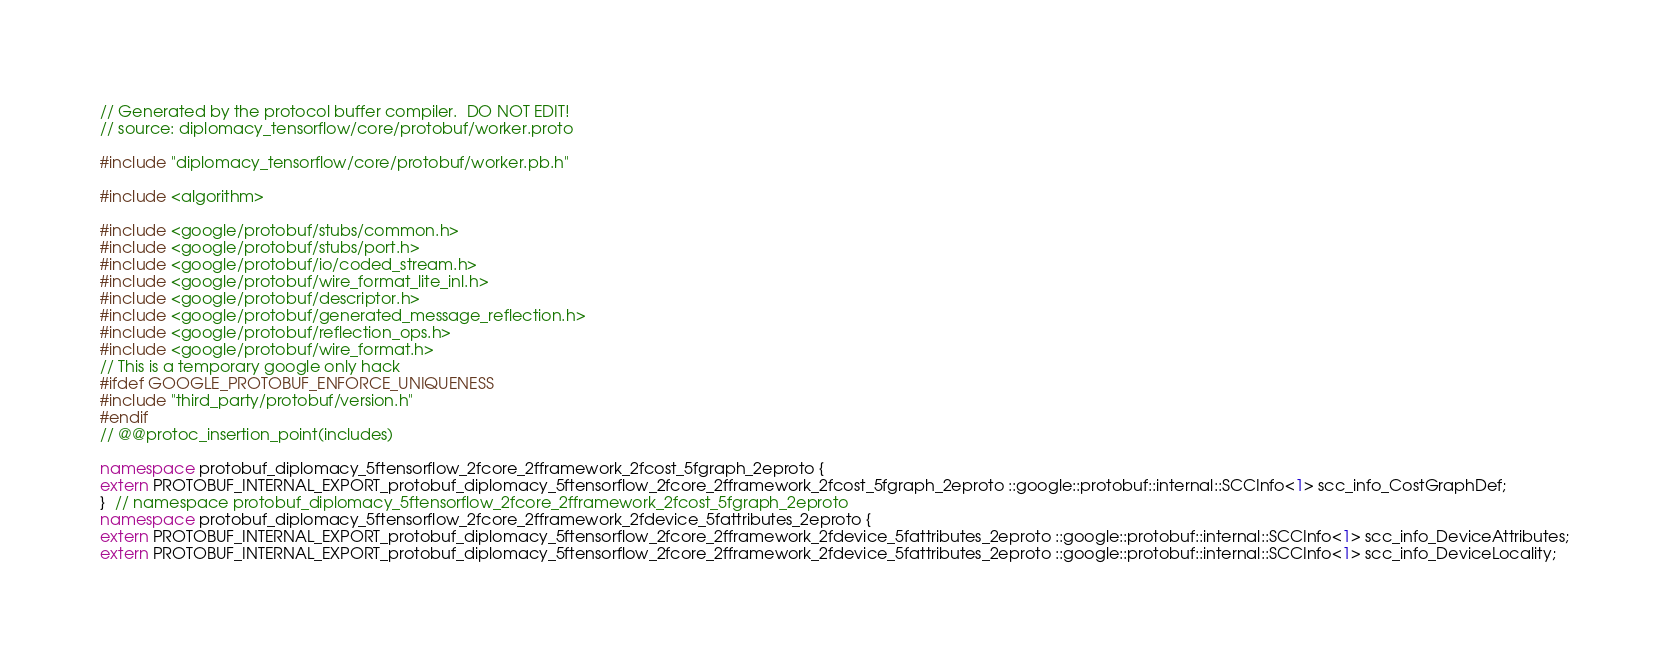Convert code to text. <code><loc_0><loc_0><loc_500><loc_500><_C++_>// Generated by the protocol buffer compiler.  DO NOT EDIT!
// source: diplomacy_tensorflow/core/protobuf/worker.proto

#include "diplomacy_tensorflow/core/protobuf/worker.pb.h"

#include <algorithm>

#include <google/protobuf/stubs/common.h>
#include <google/protobuf/stubs/port.h>
#include <google/protobuf/io/coded_stream.h>
#include <google/protobuf/wire_format_lite_inl.h>
#include <google/protobuf/descriptor.h>
#include <google/protobuf/generated_message_reflection.h>
#include <google/protobuf/reflection_ops.h>
#include <google/protobuf/wire_format.h>
// This is a temporary google only hack
#ifdef GOOGLE_PROTOBUF_ENFORCE_UNIQUENESS
#include "third_party/protobuf/version.h"
#endif
// @@protoc_insertion_point(includes)

namespace protobuf_diplomacy_5ftensorflow_2fcore_2fframework_2fcost_5fgraph_2eproto {
extern PROTOBUF_INTERNAL_EXPORT_protobuf_diplomacy_5ftensorflow_2fcore_2fframework_2fcost_5fgraph_2eproto ::google::protobuf::internal::SCCInfo<1> scc_info_CostGraphDef;
}  // namespace protobuf_diplomacy_5ftensorflow_2fcore_2fframework_2fcost_5fgraph_2eproto
namespace protobuf_diplomacy_5ftensorflow_2fcore_2fframework_2fdevice_5fattributes_2eproto {
extern PROTOBUF_INTERNAL_EXPORT_protobuf_diplomacy_5ftensorflow_2fcore_2fframework_2fdevice_5fattributes_2eproto ::google::protobuf::internal::SCCInfo<1> scc_info_DeviceAttributes;
extern PROTOBUF_INTERNAL_EXPORT_protobuf_diplomacy_5ftensorflow_2fcore_2fframework_2fdevice_5fattributes_2eproto ::google::protobuf::internal::SCCInfo<1> scc_info_DeviceLocality;</code> 